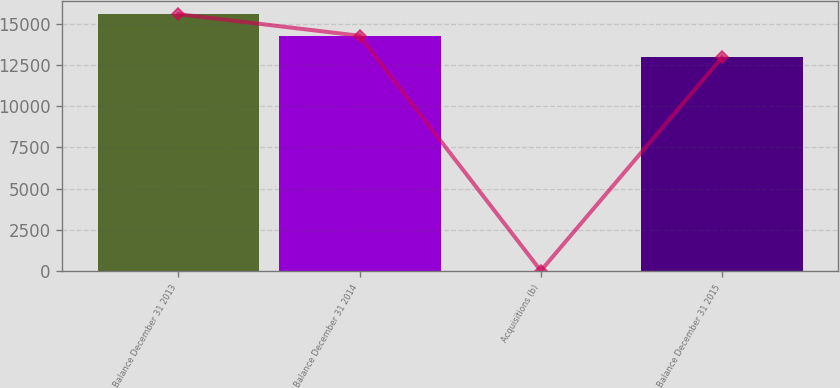Convert chart to OTSL. <chart><loc_0><loc_0><loc_500><loc_500><bar_chart><fcel>Balance December 31 2013<fcel>Balance December 31 2014<fcel>Acquisitions (b)<fcel>Balance December 31 2015<nl><fcel>15569.6<fcel>14258.3<fcel>17<fcel>12947<nl></chart> 